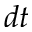<formula> <loc_0><loc_0><loc_500><loc_500>d t</formula> 